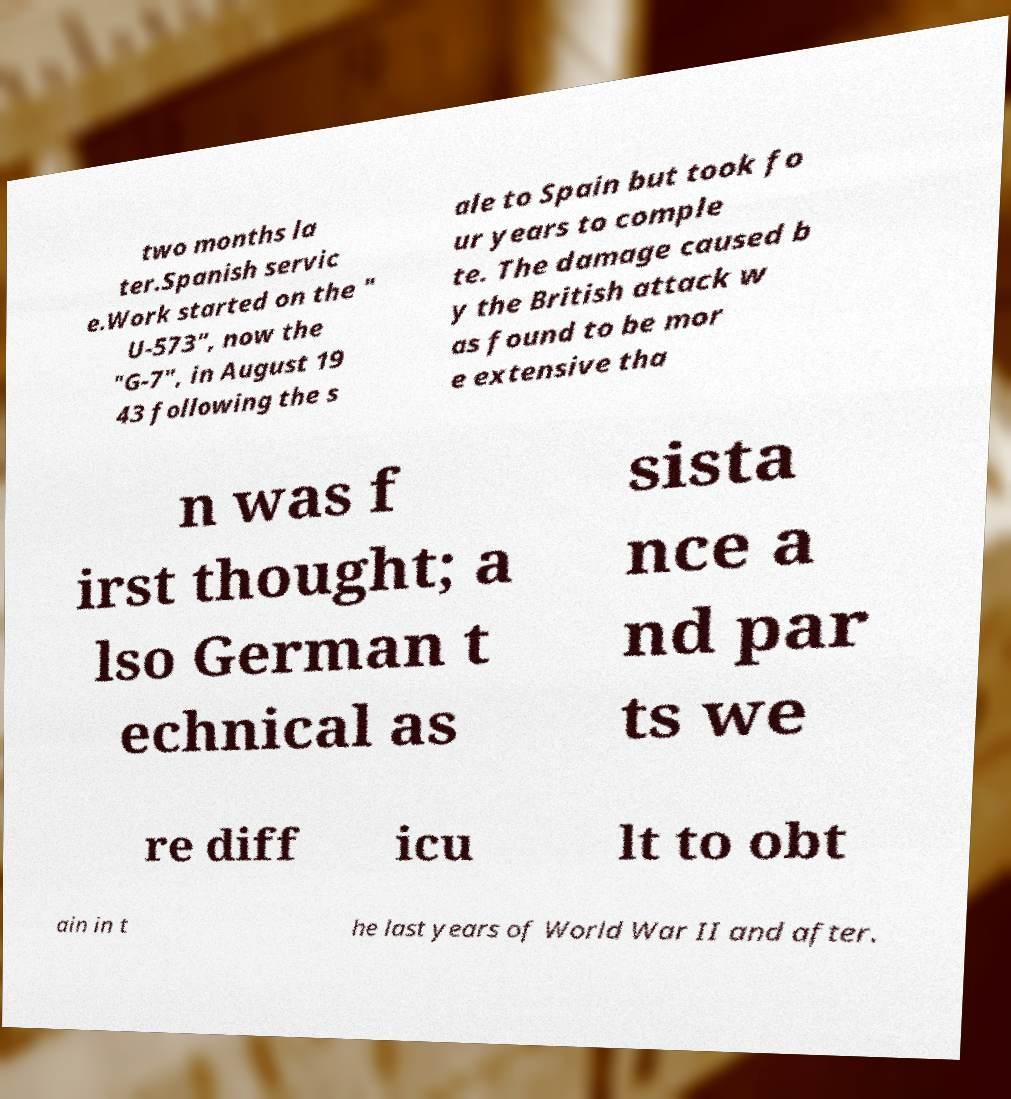For documentation purposes, I need the text within this image transcribed. Could you provide that? two months la ter.Spanish servic e.Work started on the " U-573", now the "G-7", in August 19 43 following the s ale to Spain but took fo ur years to comple te. The damage caused b y the British attack w as found to be mor e extensive tha n was f irst thought; a lso German t echnical as sista nce a nd par ts we re diff icu lt to obt ain in t he last years of World War II and after. 